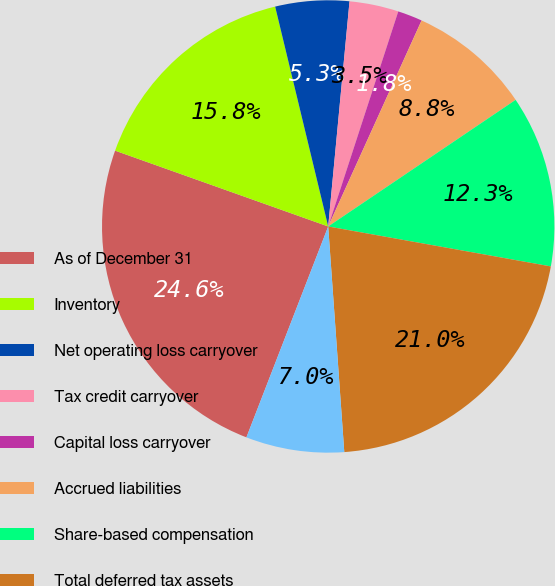Convert chart to OTSL. <chart><loc_0><loc_0><loc_500><loc_500><pie_chart><fcel>As of December 31<fcel>Inventory<fcel>Net operating loss carryover<fcel>Tax credit carryover<fcel>Capital loss carryover<fcel>Accrued liabilities<fcel>Share-based compensation<fcel>Total deferred tax assets<fcel>Less Valuation allowances<nl><fcel>24.55%<fcel>15.79%<fcel>5.27%<fcel>3.51%<fcel>1.76%<fcel>8.77%<fcel>12.28%<fcel>21.04%<fcel>7.02%<nl></chart> 